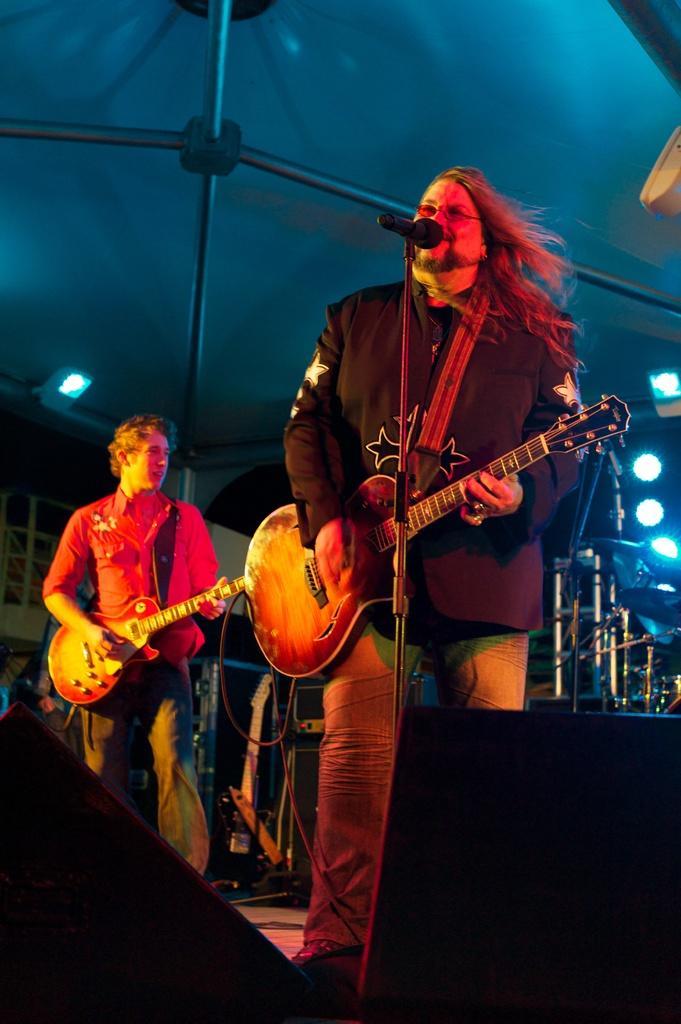In one or two sentences, can you explain what this image depicts? In this picture I can observe two men standing on the floor and playing guitars in their hands. On the right side there is mic and a stand in front of a man. I can observe some lights on the right side. The background is dark. 